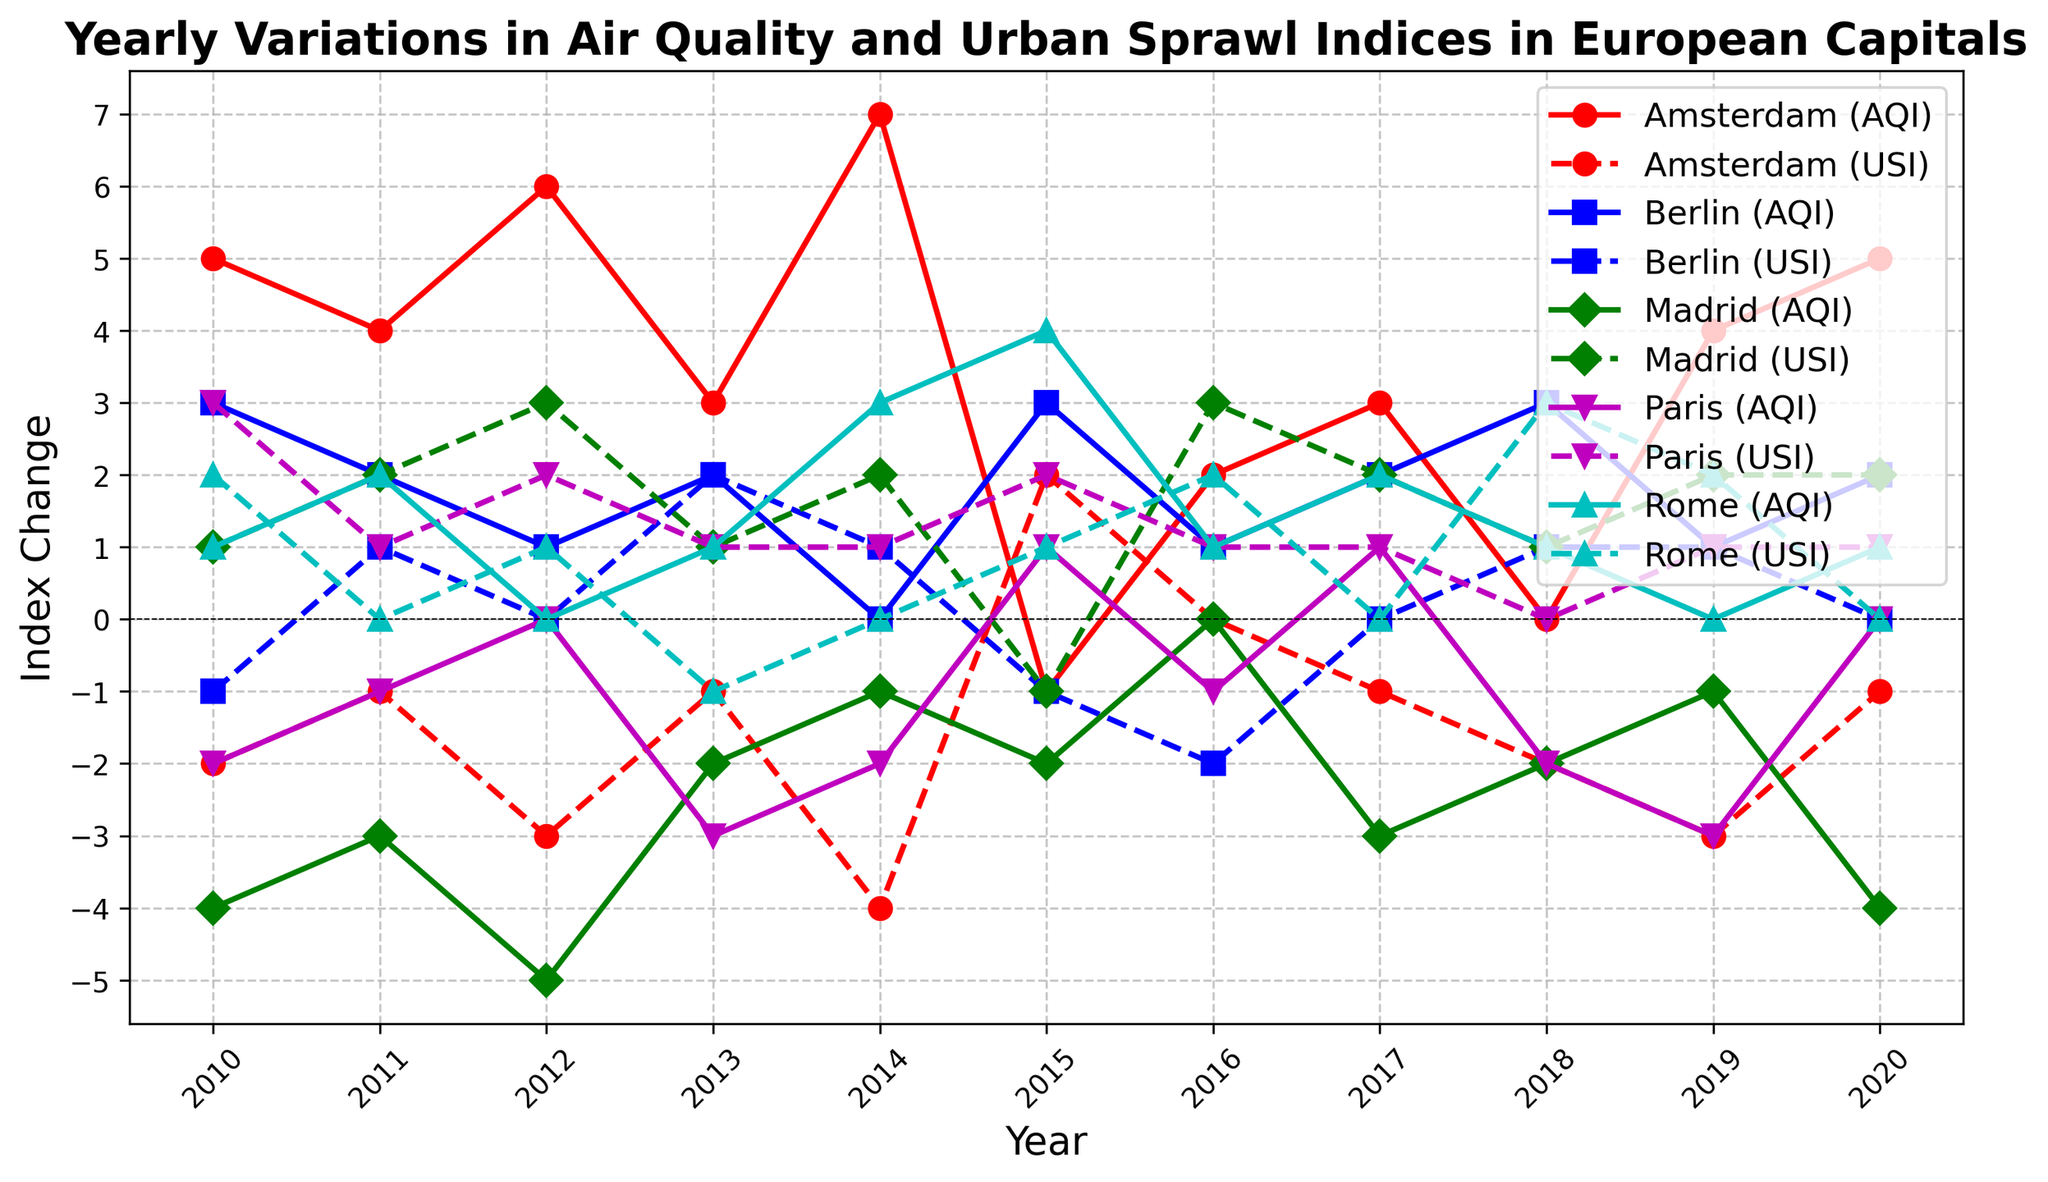What is the overall trend in the Air Quality Index Change for Amsterdam from 2010 to 2020? To determine the overall trend, observe the general direction of the line representing Amsterdam's Air Quality Index Change from 2010 to 2020. The line shows fluctuations but has an upward trend by the end of the period.
Answer: Upward How does the Urban Sprawl Index Change for Berlin in 2015 compare to that in 2016? Look at the values for Berlin's Urban Sprawl Index Change in 2015 and 2016. In 2015, it is -1, and in 2016, it is -2.
Answer: Decreased Which city experienced the highest positive change in the Air Quality Index in any single year? Identify the highest point on any city's Air Quality Index Change line. Amsterdam in 2014 experienced a change of 7.
Answer: Amsterdam In which year did Madrid experience its most negative Air Quality Index Change? Examine Madrid's Air Quality Index Change line for the lowest point. This occurs in 2012 with a change of -5.
Answer: 2012 For Paris, is there a year where both Air Quality Index Change and Urban Sprawl Index Change are equal? Compare the values of Air Quality Index Change and Urban Sprawl Index Change for Paris across all years. In 2012 and 2020, both indices have a change of 0.
Answer: 2012 and 2020 Between 2013 and 2014, which city showed the most improvement in Air Quality Index Change? Calculate the difference in Air Quality Index Change between 2013 and 2014 for each city. Amsterdam showed the most improvement, increasing from 3 to 7, a change of 4.
Answer: Amsterdam Compare the Urban Sprawl Index Change for Rome in 2010 and 2020. How do they relate? Observe Rome's Urban Sprawl Index Change values for 2010 and 2020. In 2010 it is 2, and in 2020 it is 0.
Answer: Decreased What is the correlation between the Air Quality Index Change and Urban Sprawl Index Change for Berlin from 2010 to 2020? Observe the pattern for Berlin's Air Quality Index Change and Urban Sprawl Index Change lines. When both are compared, changes aren't consistently similar or opposite, suggesting a weak or no clear correlation visually.
Answer: Weak correlation Compare the Urban Sprawl Index Change for all cities in 2018. Which city experienced the biggest positive change? Look at the Urban Sprawl Index Change values for all cities in 2018. Rome experienced the biggest positive change, with a change of 3.
Answer: Rome 